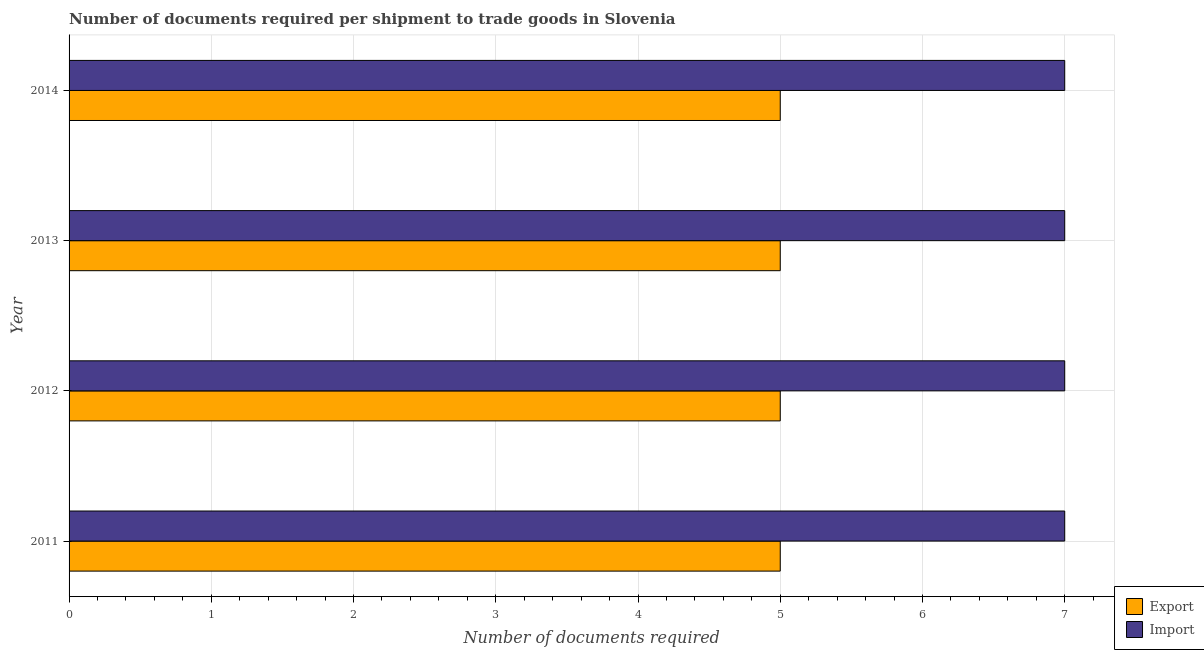Are the number of bars per tick equal to the number of legend labels?
Your answer should be compact. Yes. Are the number of bars on each tick of the Y-axis equal?
Your answer should be very brief. Yes. How many bars are there on the 2nd tick from the top?
Offer a terse response. 2. What is the number of documents required to export goods in 2011?
Offer a terse response. 5. Across all years, what is the maximum number of documents required to import goods?
Your answer should be compact. 7. Across all years, what is the minimum number of documents required to import goods?
Provide a short and direct response. 7. In which year was the number of documents required to import goods minimum?
Offer a terse response. 2011. What is the total number of documents required to import goods in the graph?
Provide a succinct answer. 28. What is the difference between the number of documents required to import goods in 2014 and the number of documents required to export goods in 2011?
Your answer should be compact. 2. In the year 2012, what is the difference between the number of documents required to export goods and number of documents required to import goods?
Ensure brevity in your answer.  -2. Is the difference between the number of documents required to export goods in 2011 and 2014 greater than the difference between the number of documents required to import goods in 2011 and 2014?
Make the answer very short. No. In how many years, is the number of documents required to import goods greater than the average number of documents required to import goods taken over all years?
Give a very brief answer. 0. Is the sum of the number of documents required to export goods in 2012 and 2013 greater than the maximum number of documents required to import goods across all years?
Offer a terse response. Yes. What does the 1st bar from the top in 2014 represents?
Provide a short and direct response. Import. What does the 2nd bar from the bottom in 2011 represents?
Provide a short and direct response. Import. Are all the bars in the graph horizontal?
Offer a very short reply. Yes. What is the difference between two consecutive major ticks on the X-axis?
Ensure brevity in your answer.  1. Does the graph contain any zero values?
Give a very brief answer. No. How many legend labels are there?
Offer a terse response. 2. What is the title of the graph?
Keep it short and to the point. Number of documents required per shipment to trade goods in Slovenia. What is the label or title of the X-axis?
Make the answer very short. Number of documents required. What is the label or title of the Y-axis?
Offer a very short reply. Year. What is the Number of documents required of Export in 2011?
Your answer should be very brief. 5. What is the Number of documents required of Import in 2012?
Make the answer very short. 7. What is the Number of documents required of Export in 2013?
Give a very brief answer. 5. What is the Number of documents required of Import in 2013?
Provide a short and direct response. 7. What is the Number of documents required of Import in 2014?
Make the answer very short. 7. Across all years, what is the maximum Number of documents required in Import?
Your answer should be compact. 7. Across all years, what is the minimum Number of documents required of Export?
Your answer should be compact. 5. What is the total Number of documents required of Import in the graph?
Offer a terse response. 28. What is the difference between the Number of documents required of Export in 2011 and that in 2012?
Ensure brevity in your answer.  0. What is the difference between the Number of documents required in Export in 2011 and that in 2014?
Offer a very short reply. 0. What is the difference between the Number of documents required of Import in 2011 and that in 2014?
Give a very brief answer. 0. What is the difference between the Number of documents required of Export in 2012 and that in 2013?
Provide a succinct answer. 0. What is the difference between the Number of documents required in Export in 2012 and that in 2014?
Your response must be concise. 0. What is the difference between the Number of documents required in Import in 2012 and that in 2014?
Give a very brief answer. 0. What is the difference between the Number of documents required of Export in 2011 and the Number of documents required of Import in 2012?
Ensure brevity in your answer.  -2. What is the difference between the Number of documents required of Export in 2011 and the Number of documents required of Import in 2013?
Offer a very short reply. -2. What is the difference between the Number of documents required in Export in 2011 and the Number of documents required in Import in 2014?
Give a very brief answer. -2. What is the average Number of documents required of Export per year?
Give a very brief answer. 5. In the year 2012, what is the difference between the Number of documents required in Export and Number of documents required in Import?
Give a very brief answer. -2. In the year 2014, what is the difference between the Number of documents required of Export and Number of documents required of Import?
Your response must be concise. -2. What is the ratio of the Number of documents required of Export in 2011 to that in 2012?
Ensure brevity in your answer.  1. What is the ratio of the Number of documents required of Import in 2011 to that in 2012?
Your answer should be compact. 1. What is the ratio of the Number of documents required of Export in 2011 to that in 2013?
Provide a succinct answer. 1. What is the ratio of the Number of documents required in Import in 2011 to that in 2014?
Offer a very short reply. 1. What is the ratio of the Number of documents required in Export in 2012 to that in 2014?
Provide a short and direct response. 1. What is the ratio of the Number of documents required in Import in 2012 to that in 2014?
Your answer should be compact. 1. What is the ratio of the Number of documents required in Export in 2013 to that in 2014?
Your answer should be very brief. 1. What is the difference between the highest and the lowest Number of documents required in Export?
Your answer should be compact. 0. What is the difference between the highest and the lowest Number of documents required in Import?
Provide a succinct answer. 0. 